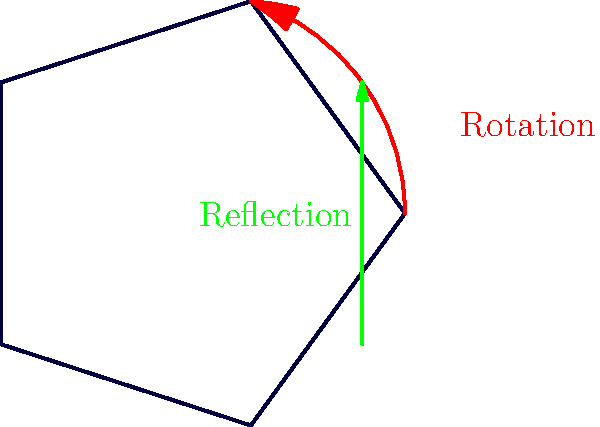As a seasoned executive, you understand the importance of symmetry in business strategies. Consider the symmetry group of a regular pentagon, illustrated above with rotation and reflection operations. How many distinct symmetries (including the identity) does this group contain, and what is the name of this group? Let's approach this step-by-step:

1. First, we need to identify the types of symmetries for a regular pentagon:
   a. Rotational symmetries
   b. Reflection symmetries
   c. Identity symmetry (no change)

2. Rotational symmetries:
   - A pentagon can be rotated by multiples of 72° (360° / 5) to match itself.
   - There are 5 rotations: 0° (identity), 72°, 144°, 216°, and 288°.

3. Reflection symmetries:
   - A pentagon has 5 lines of reflection, each passing through a vertex and the midpoint of the opposite side.

4. Counting the symmetries:
   - 5 rotations (including the identity rotation of 0°)
   - 5 reflections
   - Total: 5 + 5 = 10 symmetries

5. The group formed by these symmetries is called the Dihedral group of order 10, denoted as $D_5$ or $D_{10}$ (depending on the notation system).

6. The order of this group (number of elements) is 10, which matches our count of distinct symmetries.
Answer: 10 symmetries; Dihedral group $D_5$ (or $D_{10}$) 